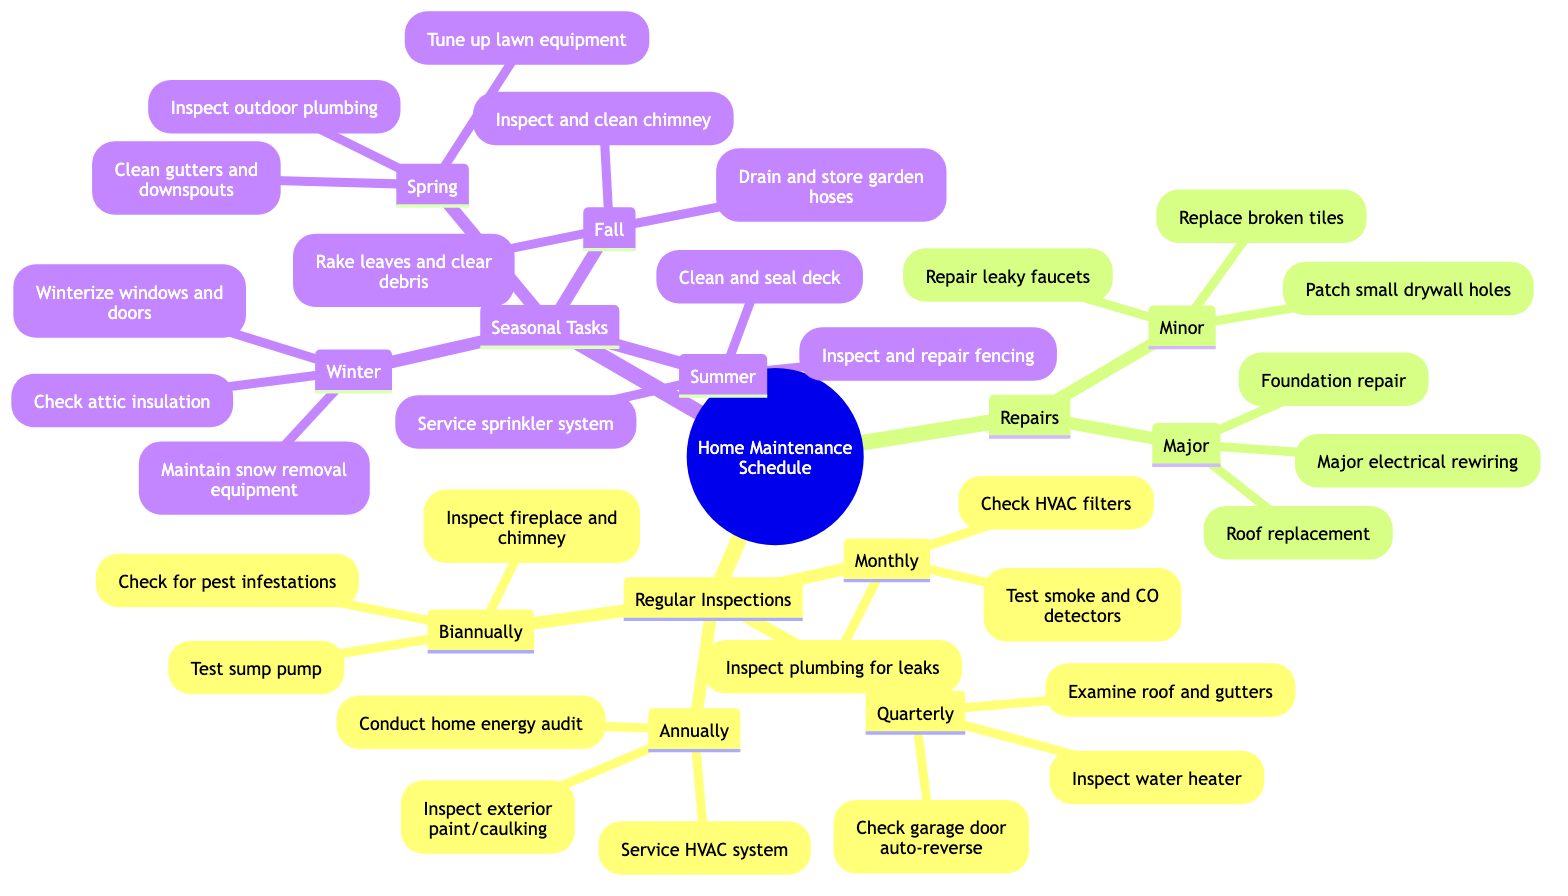What are the minor repairs listed? The diagram lists "Repair leaky faucets," "Patch small drywall holes," and "Replace broken tiles" under the minor repairs section. These are the tasks categorized as minor repairs.
Answer: Repair leaky faucets, Patch small drywall holes, Replace broken tiles How many annual inspections are listed? The annual inspections include "Conduct a home energy audit," "Inspect exterior paint and caulking," and "Service HVAC system." There are three distinct tasks listed in the annual category.
Answer: 3 What seasonal tasks are recommended for winter? The winter seasonal tasks include "Winterize windows and doors," "Check attic insulation," and "Inspect and maintain snow removal equipment." These tasks focus on preparing the home for winter.
Answer: Winterize windows and doors, Check attic insulation, Inspect and maintain snow removal equipment Which type of repairs includes roof replacement? The roof replacement falls under the major repairs category. When looking at the Repairs section, the major tasks include significant undertakings, of which roof replacement is a key example.
Answer: Major Which tasks are advised for fall? The fall seasonal tasks are "Rake leaves and clear debris," "Inspect and clean chimney," and "Drain and store garden hoses." These tasks are essential for home maintenance as the season transitions.
Answer: Rake leaves and clear debris, Inspect and clean chimney, Drain and store garden hoses What frequency do you check HVAC filters? Checking HVAC filters is scheduled monthly, as indicated in the Regular Inspections section under Monthly. This frequency is important for maintaining good air quality and system efficiency.
Answer: Monthly How many biannual inspections are there? There are three biannual inspections listed: "Inspect fireplace and chimney," "Test sump pump," and "Check for pest infestations." This grouping indicates that these tasks should be done twice a year.
Answer: 3 Which quarterly task involves the water heater? The task "Inspect water heater for proper function" is specifically mentioned in the quarterly category of the Regular Inspections section. This indicates a focus on ensuring the water heater operates correctly every three months.
Answer: Inspect water heater for proper function 